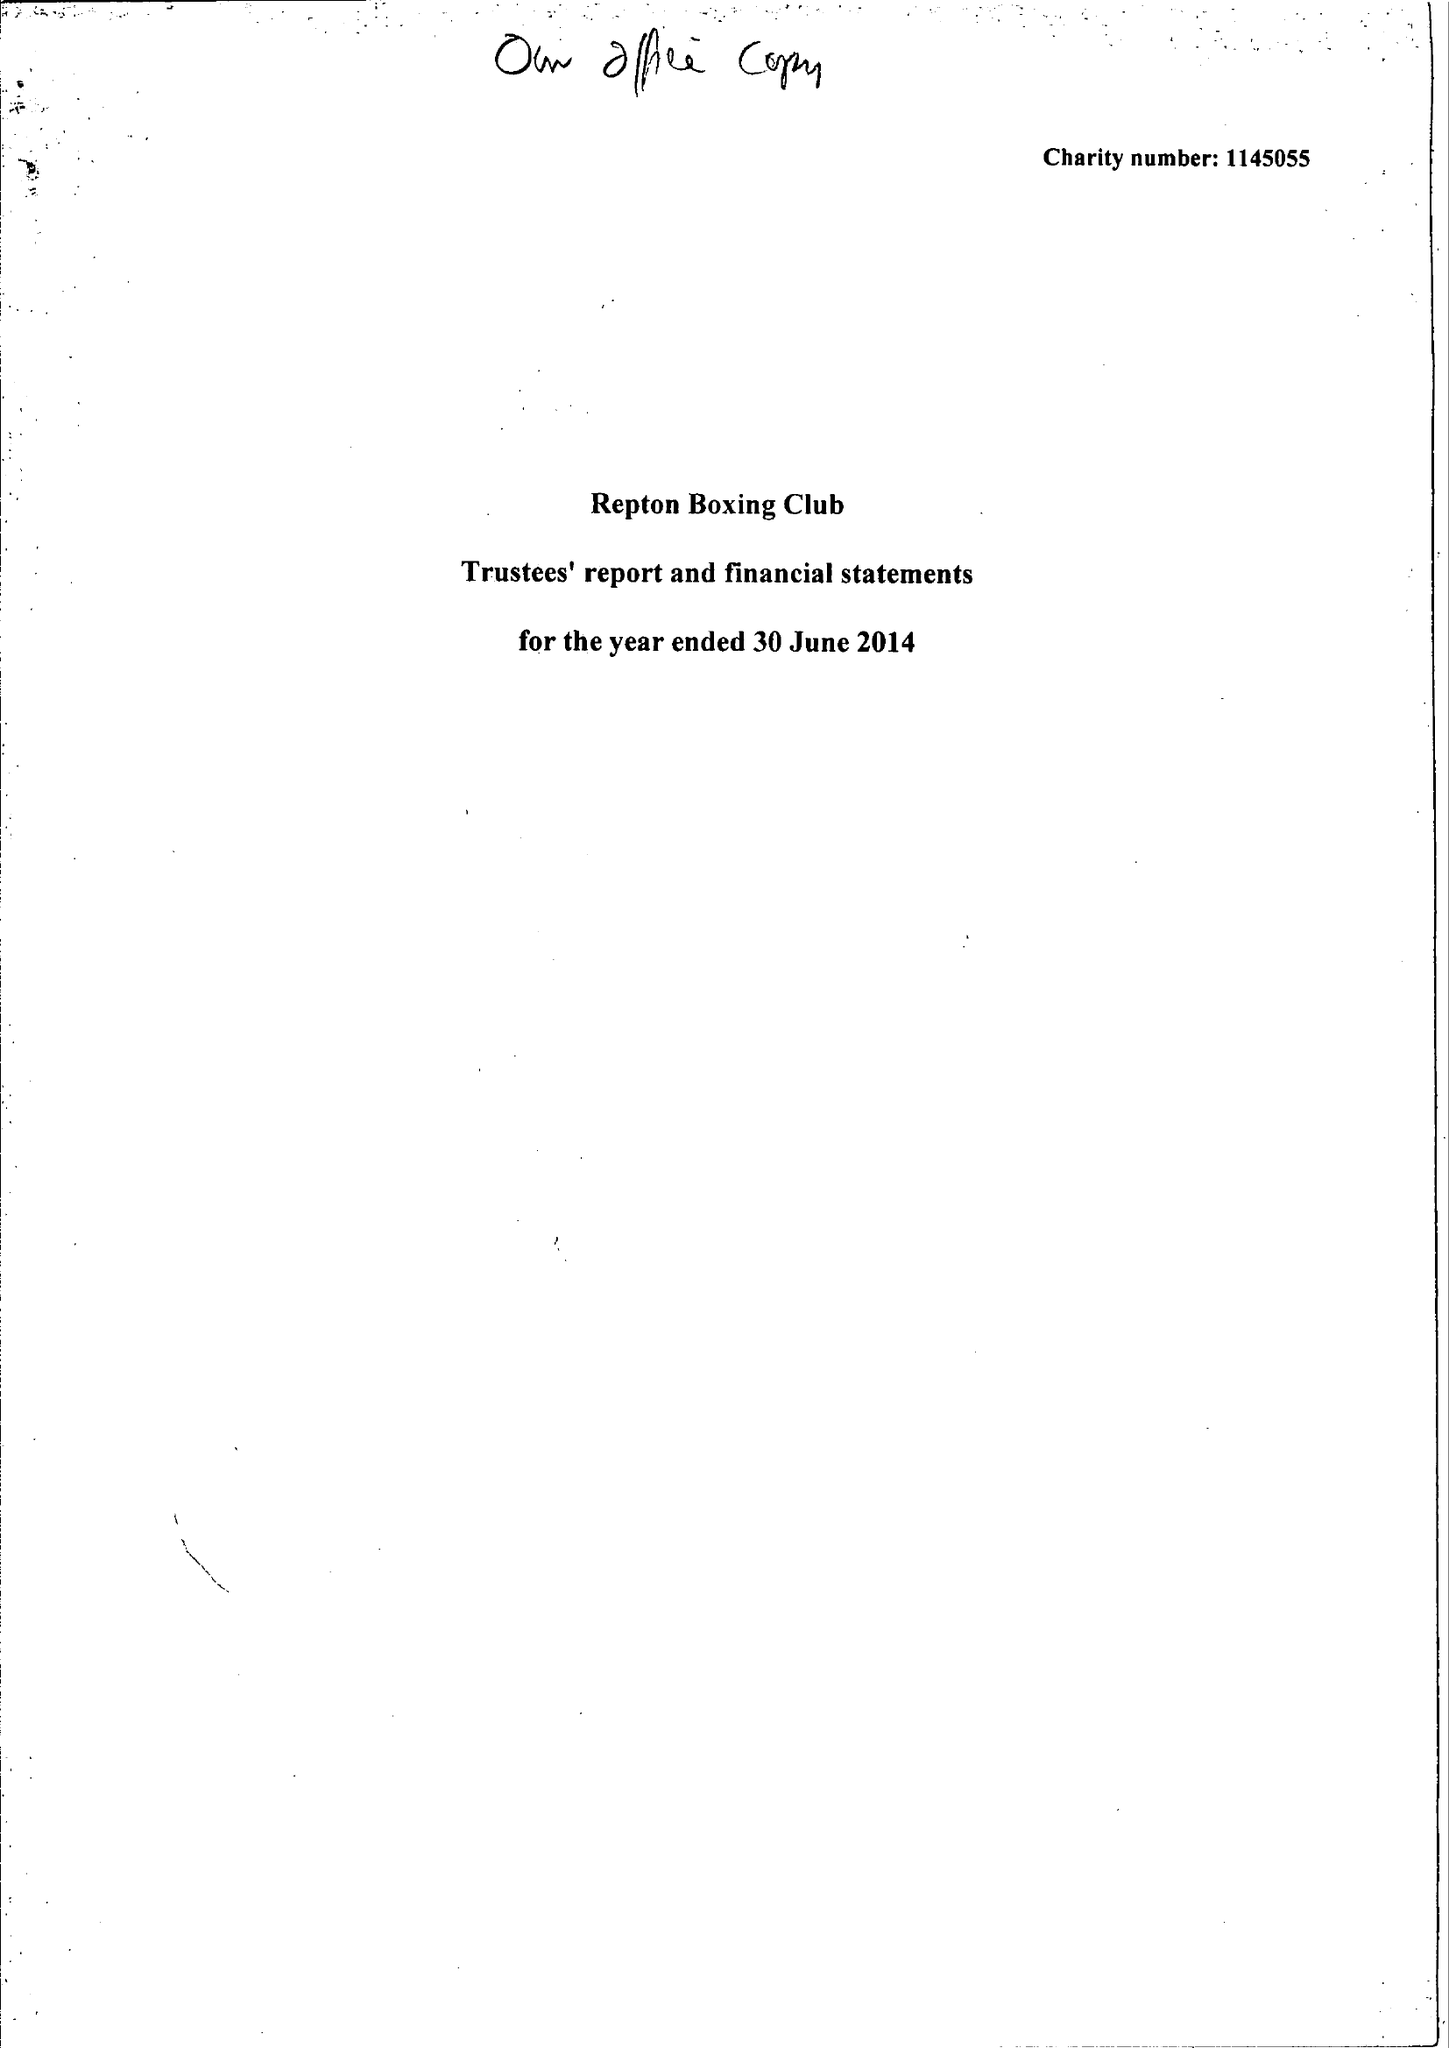What is the value for the report_date?
Answer the question using a single word or phrase. 2014-06-30 